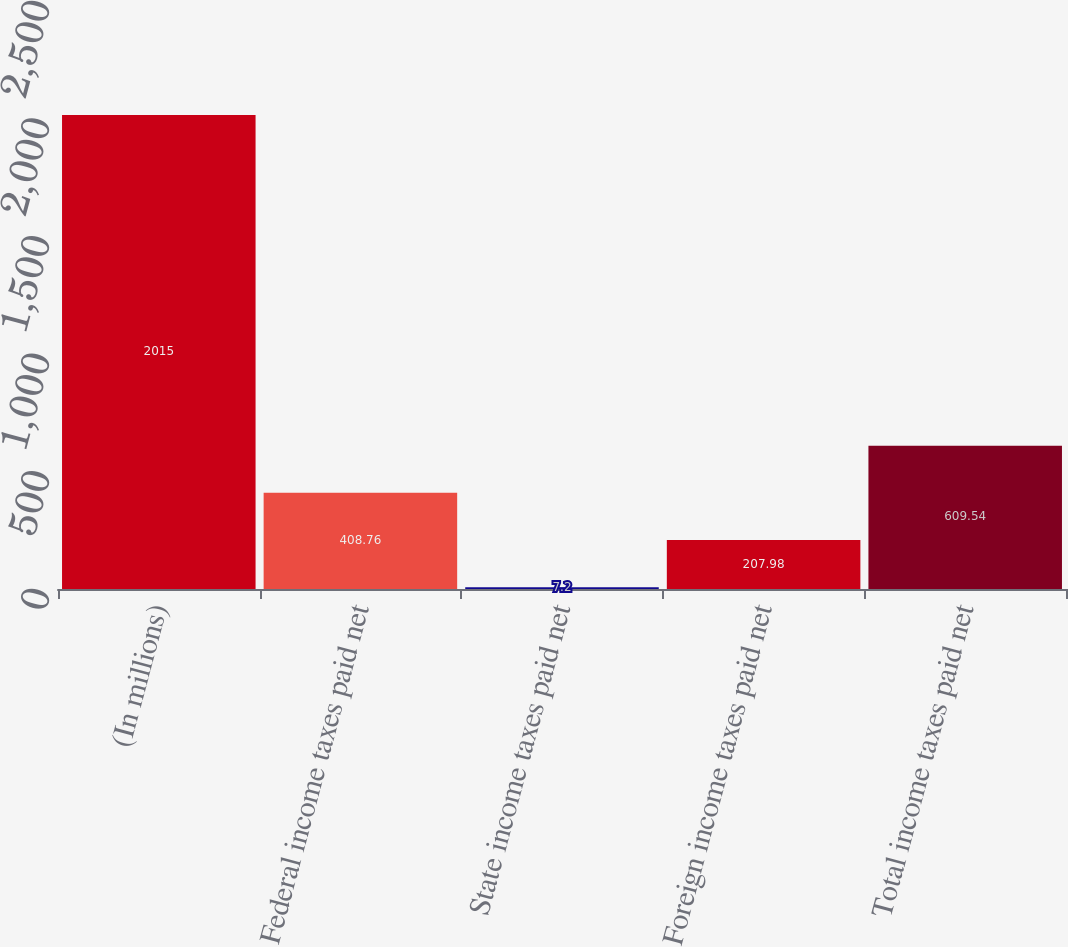Convert chart to OTSL. <chart><loc_0><loc_0><loc_500><loc_500><bar_chart><fcel>(In millions)<fcel>Federal income taxes paid net<fcel>State income taxes paid net<fcel>Foreign income taxes paid net<fcel>Total income taxes paid net<nl><fcel>2015<fcel>408.76<fcel>7.2<fcel>207.98<fcel>609.54<nl></chart> 